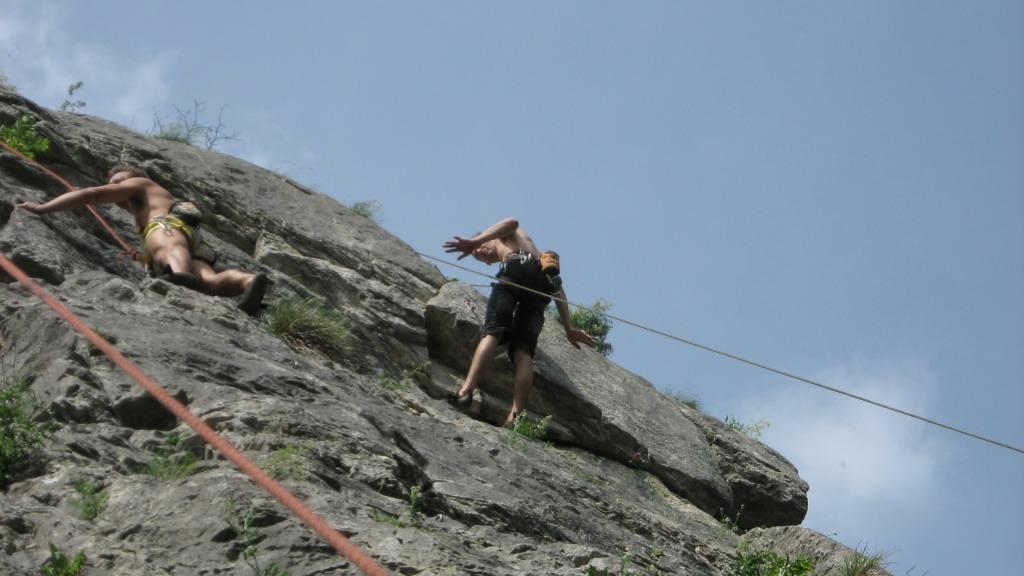How many people are in the image? There are two men in the image. What are the men doing in the image? The men are climbing rocks. What can be seen attached to the rocks in the image? There are red-colored ropes in the image. What is at the bottom of the image? There is a rock at the bottom of the image. What is visible at the top of the image? The sky is visible at the top of the image. What type of furniture can be seen in the image? There is no furniture present in the image; it features two men climbing rocks with red-colored ropes. 